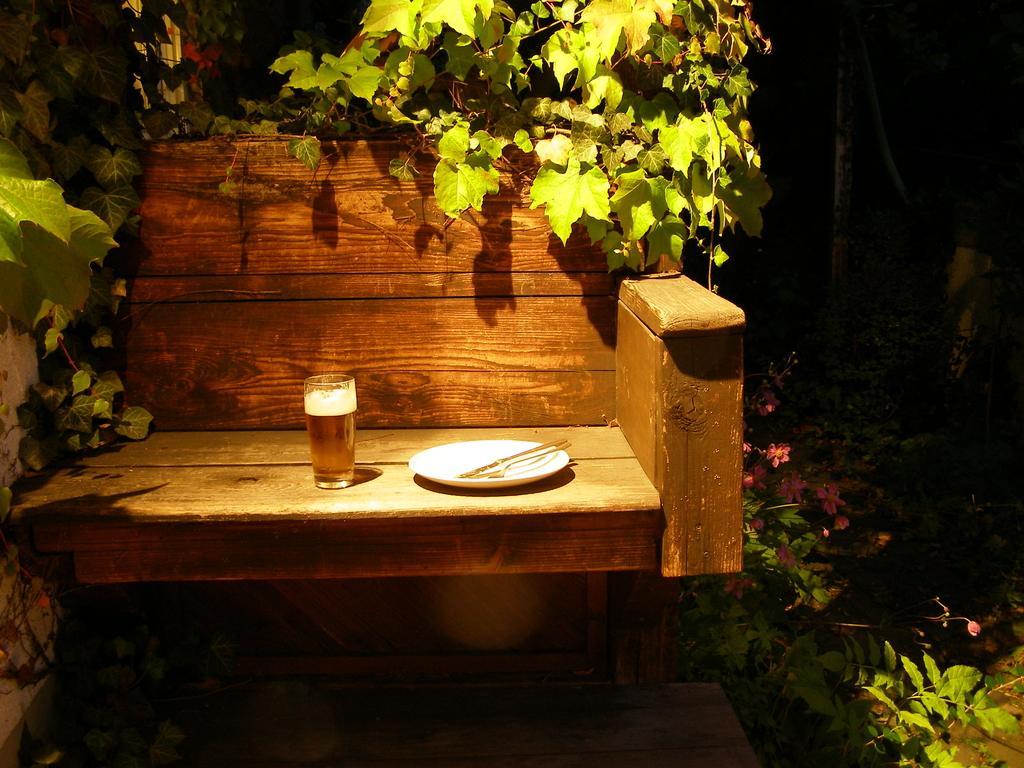In one or two sentences, can you explain what this image depicts? In this picture there is a wooden chair on the left side of the image, on which there is a plate and a glass, there are plants on the left and right side of the image. 